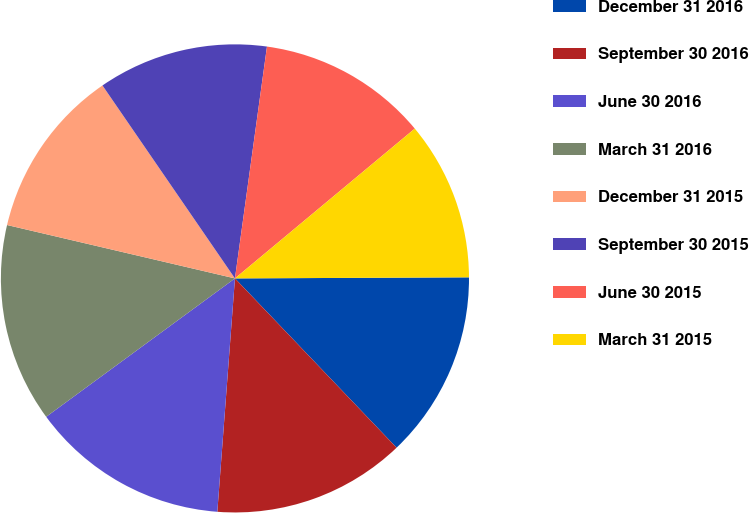Convert chart. <chart><loc_0><loc_0><loc_500><loc_500><pie_chart><fcel>December 31 2016<fcel>September 30 2016<fcel>June 30 2016<fcel>March 31 2016<fcel>December 31 2015<fcel>September 30 2015<fcel>June 30 2015<fcel>March 31 2015<nl><fcel>12.94%<fcel>13.33%<fcel>13.73%<fcel>13.73%<fcel>11.76%<fcel>11.76%<fcel>11.76%<fcel>10.98%<nl></chart> 